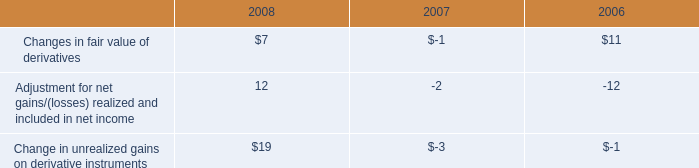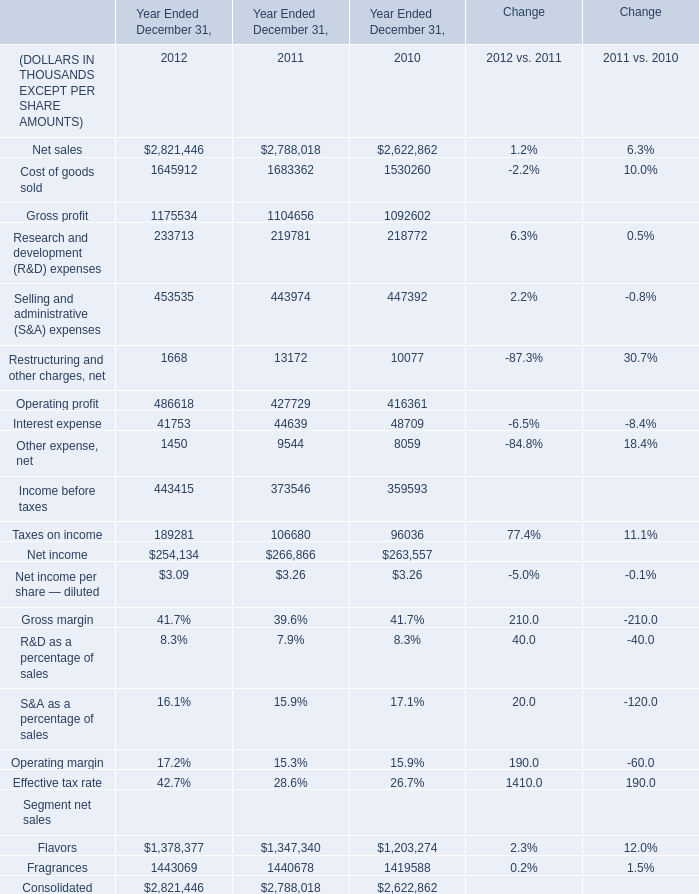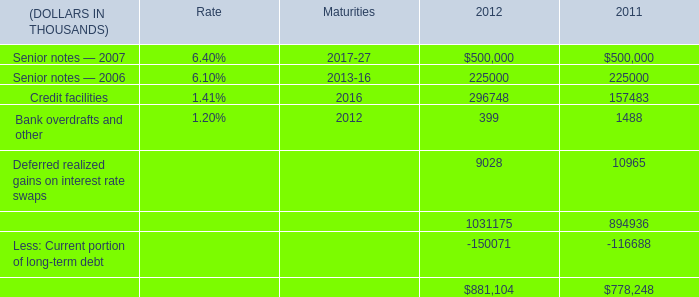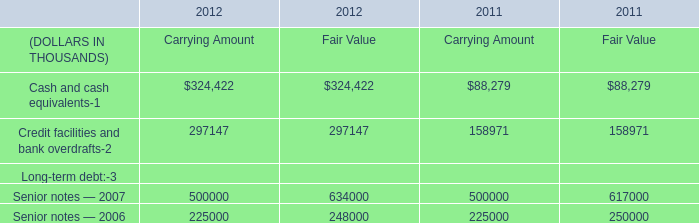What is the average value of Credit facilities and bank overdrafts of Fair Value in Table 3 and Credit facilities in Table 2 in 2011? (in thousand) 
Computations: ((158971 + 157483) / 2)
Answer: 158227.0. 